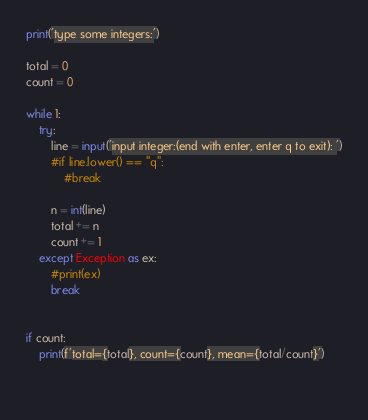Convert code to text. <code><loc_0><loc_0><loc_500><loc_500><_Python_>print('type some integers:')

total = 0
count = 0

while 1:
    try:
        line = input('input integer:(end with enter, enter q to exit): ')
        #if line.lower() == "q":
            #break
        
        n = int(line)
        total += n
        count += 1
    except Exception as ex:
        #print(ex)
        break

        
if count:
    print(f'total={total}, count={count}, mean={total/count}')
    
    </code> 